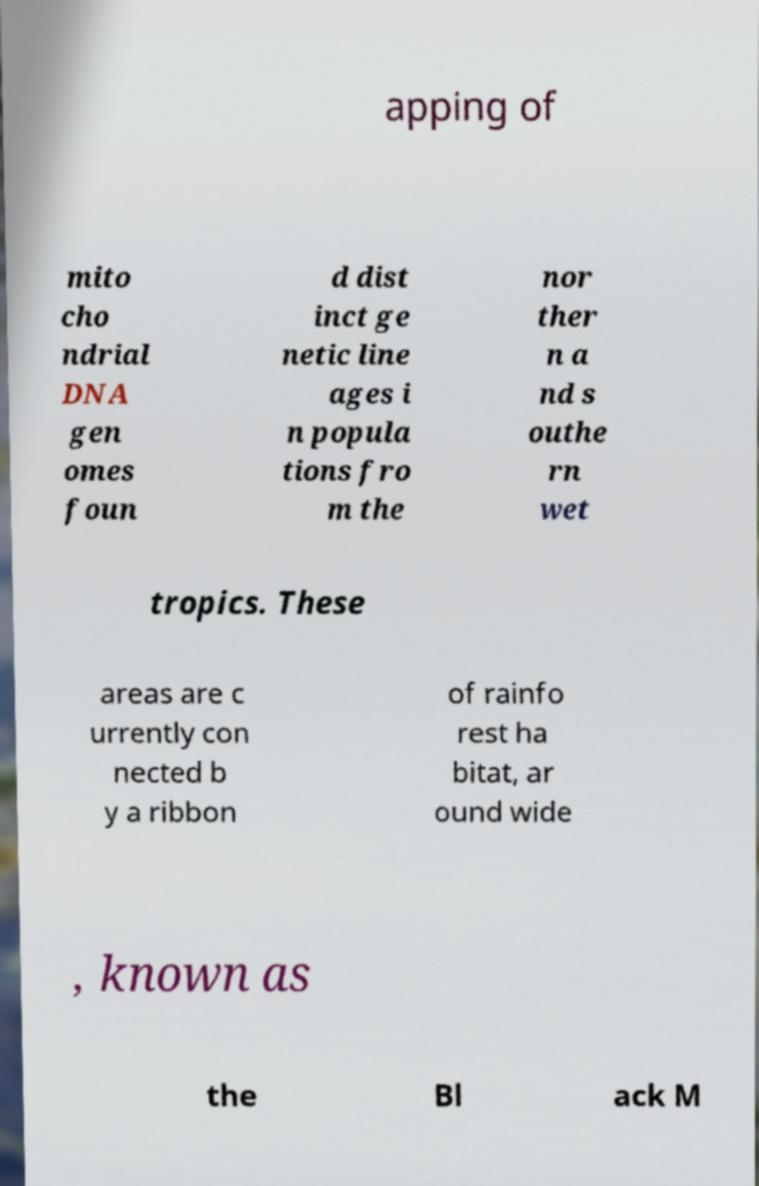Please identify and transcribe the text found in this image. apping of mito cho ndrial DNA gen omes foun d dist inct ge netic line ages i n popula tions fro m the nor ther n a nd s outhe rn wet tropics. These areas are c urrently con nected b y a ribbon of rainfo rest ha bitat, ar ound wide , known as the Bl ack M 